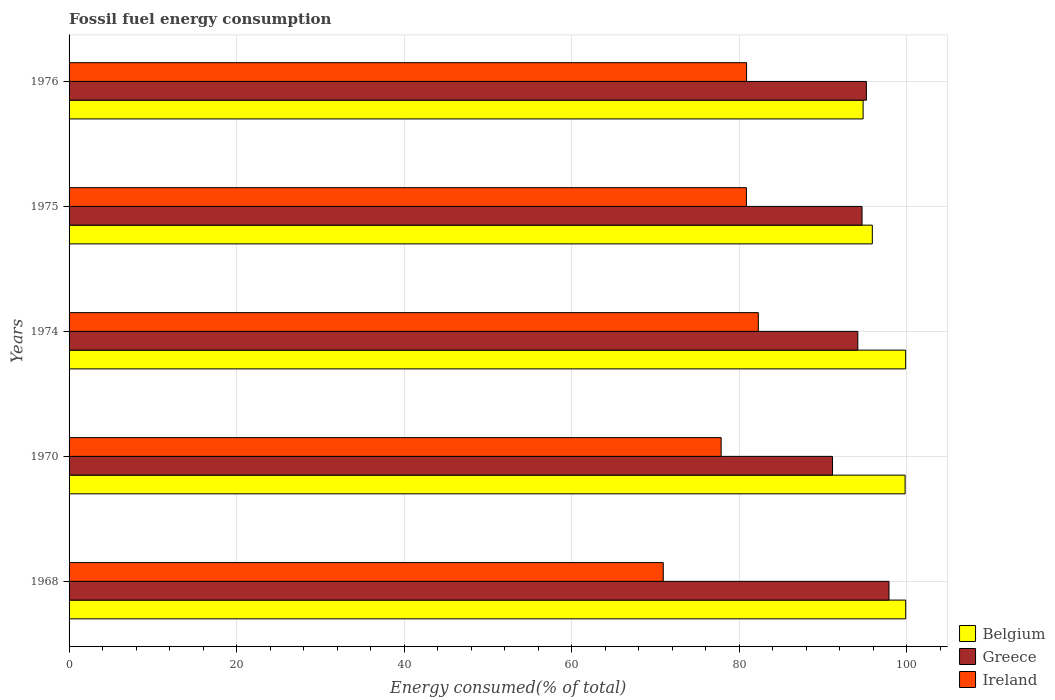How many different coloured bars are there?
Provide a short and direct response. 3. What is the label of the 5th group of bars from the top?
Offer a terse response. 1968. What is the percentage of energy consumed in Belgium in 1975?
Offer a very short reply. 95.91. Across all years, what is the maximum percentage of energy consumed in Belgium?
Keep it short and to the point. 99.9. Across all years, what is the minimum percentage of energy consumed in Greece?
Offer a very short reply. 91.16. In which year was the percentage of energy consumed in Belgium maximum?
Your answer should be compact. 1968. What is the total percentage of energy consumed in Ireland in the graph?
Give a very brief answer. 392.9. What is the difference between the percentage of energy consumed in Belgium in 1974 and that in 1976?
Ensure brevity in your answer.  5.08. What is the difference between the percentage of energy consumed in Belgium in 1968 and the percentage of energy consumed in Ireland in 1974?
Offer a terse response. 17.6. What is the average percentage of energy consumed in Belgium per year?
Give a very brief answer. 98.07. In the year 1974, what is the difference between the percentage of energy consumed in Greece and percentage of energy consumed in Belgium?
Ensure brevity in your answer.  -5.71. What is the ratio of the percentage of energy consumed in Ireland in 1970 to that in 1975?
Provide a short and direct response. 0.96. Is the difference between the percentage of energy consumed in Greece in 1968 and 1974 greater than the difference between the percentage of energy consumed in Belgium in 1968 and 1974?
Offer a terse response. Yes. What is the difference between the highest and the second highest percentage of energy consumed in Greece?
Your response must be concise. 2.7. What is the difference between the highest and the lowest percentage of energy consumed in Ireland?
Your answer should be very brief. 11.35. What does the 3rd bar from the top in 1974 represents?
Your response must be concise. Belgium. What does the 3rd bar from the bottom in 1975 represents?
Provide a succinct answer. Ireland. Is it the case that in every year, the sum of the percentage of energy consumed in Greece and percentage of energy consumed in Ireland is greater than the percentage of energy consumed in Belgium?
Offer a terse response. Yes. How many years are there in the graph?
Your response must be concise. 5. Does the graph contain any zero values?
Provide a succinct answer. No. Does the graph contain grids?
Provide a short and direct response. Yes. How many legend labels are there?
Ensure brevity in your answer.  3. What is the title of the graph?
Provide a short and direct response. Fossil fuel energy consumption. What is the label or title of the X-axis?
Your answer should be very brief. Energy consumed(% of total). What is the label or title of the Y-axis?
Offer a terse response. Years. What is the Energy consumed(% of total) of Belgium in 1968?
Your response must be concise. 99.9. What is the Energy consumed(% of total) of Greece in 1968?
Your answer should be very brief. 97.91. What is the Energy consumed(% of total) of Ireland in 1968?
Provide a short and direct response. 70.95. What is the Energy consumed(% of total) in Belgium in 1970?
Offer a terse response. 99.83. What is the Energy consumed(% of total) of Greece in 1970?
Make the answer very short. 91.16. What is the Energy consumed(% of total) in Ireland in 1970?
Make the answer very short. 77.86. What is the Energy consumed(% of total) of Belgium in 1974?
Provide a succinct answer. 99.89. What is the Energy consumed(% of total) of Greece in 1974?
Give a very brief answer. 94.18. What is the Energy consumed(% of total) in Ireland in 1974?
Provide a short and direct response. 82.3. What is the Energy consumed(% of total) in Belgium in 1975?
Your response must be concise. 95.91. What is the Energy consumed(% of total) in Greece in 1975?
Your response must be concise. 94.69. What is the Energy consumed(% of total) in Ireland in 1975?
Your answer should be compact. 80.88. What is the Energy consumed(% of total) in Belgium in 1976?
Keep it short and to the point. 94.81. What is the Energy consumed(% of total) of Greece in 1976?
Your answer should be very brief. 95.21. What is the Energy consumed(% of total) of Ireland in 1976?
Provide a succinct answer. 80.9. Across all years, what is the maximum Energy consumed(% of total) in Belgium?
Offer a terse response. 99.9. Across all years, what is the maximum Energy consumed(% of total) of Greece?
Offer a terse response. 97.91. Across all years, what is the maximum Energy consumed(% of total) in Ireland?
Offer a very short reply. 82.3. Across all years, what is the minimum Energy consumed(% of total) of Belgium?
Provide a succinct answer. 94.81. Across all years, what is the minimum Energy consumed(% of total) in Greece?
Provide a short and direct response. 91.16. Across all years, what is the minimum Energy consumed(% of total) of Ireland?
Offer a very short reply. 70.95. What is the total Energy consumed(% of total) of Belgium in the graph?
Provide a short and direct response. 490.35. What is the total Energy consumed(% of total) in Greece in the graph?
Offer a terse response. 473.14. What is the total Energy consumed(% of total) of Ireland in the graph?
Give a very brief answer. 392.9. What is the difference between the Energy consumed(% of total) of Belgium in 1968 and that in 1970?
Give a very brief answer. 0.07. What is the difference between the Energy consumed(% of total) of Greece in 1968 and that in 1970?
Provide a succinct answer. 6.75. What is the difference between the Energy consumed(% of total) in Ireland in 1968 and that in 1970?
Your answer should be very brief. -6.91. What is the difference between the Energy consumed(% of total) of Belgium in 1968 and that in 1974?
Provide a short and direct response. 0.01. What is the difference between the Energy consumed(% of total) of Greece in 1968 and that in 1974?
Your answer should be compact. 3.72. What is the difference between the Energy consumed(% of total) in Ireland in 1968 and that in 1974?
Offer a terse response. -11.35. What is the difference between the Energy consumed(% of total) in Belgium in 1968 and that in 1975?
Your answer should be compact. 3.99. What is the difference between the Energy consumed(% of total) in Greece in 1968 and that in 1975?
Keep it short and to the point. 3.22. What is the difference between the Energy consumed(% of total) of Ireland in 1968 and that in 1975?
Your answer should be very brief. -9.93. What is the difference between the Energy consumed(% of total) of Belgium in 1968 and that in 1976?
Provide a short and direct response. 5.09. What is the difference between the Energy consumed(% of total) in Greece in 1968 and that in 1976?
Your answer should be very brief. 2.7. What is the difference between the Energy consumed(% of total) in Ireland in 1968 and that in 1976?
Ensure brevity in your answer.  -9.95. What is the difference between the Energy consumed(% of total) of Belgium in 1970 and that in 1974?
Offer a very short reply. -0.07. What is the difference between the Energy consumed(% of total) of Greece in 1970 and that in 1974?
Ensure brevity in your answer.  -3.02. What is the difference between the Energy consumed(% of total) in Ireland in 1970 and that in 1974?
Offer a terse response. -4.44. What is the difference between the Energy consumed(% of total) of Belgium in 1970 and that in 1975?
Offer a terse response. 3.92. What is the difference between the Energy consumed(% of total) of Greece in 1970 and that in 1975?
Provide a short and direct response. -3.53. What is the difference between the Energy consumed(% of total) in Ireland in 1970 and that in 1975?
Provide a short and direct response. -3.02. What is the difference between the Energy consumed(% of total) in Belgium in 1970 and that in 1976?
Your answer should be compact. 5.02. What is the difference between the Energy consumed(% of total) in Greece in 1970 and that in 1976?
Keep it short and to the point. -4.05. What is the difference between the Energy consumed(% of total) of Ireland in 1970 and that in 1976?
Give a very brief answer. -3.04. What is the difference between the Energy consumed(% of total) in Belgium in 1974 and that in 1975?
Your answer should be compact. 3.98. What is the difference between the Energy consumed(% of total) of Greece in 1974 and that in 1975?
Make the answer very short. -0.51. What is the difference between the Energy consumed(% of total) in Ireland in 1974 and that in 1975?
Provide a short and direct response. 1.42. What is the difference between the Energy consumed(% of total) of Belgium in 1974 and that in 1976?
Offer a terse response. 5.08. What is the difference between the Energy consumed(% of total) in Greece in 1974 and that in 1976?
Keep it short and to the point. -1.02. What is the difference between the Energy consumed(% of total) of Ireland in 1974 and that in 1976?
Offer a very short reply. 1.4. What is the difference between the Energy consumed(% of total) in Belgium in 1975 and that in 1976?
Make the answer very short. 1.1. What is the difference between the Energy consumed(% of total) of Greece in 1975 and that in 1976?
Keep it short and to the point. -0.52. What is the difference between the Energy consumed(% of total) in Ireland in 1975 and that in 1976?
Keep it short and to the point. -0.02. What is the difference between the Energy consumed(% of total) in Belgium in 1968 and the Energy consumed(% of total) in Greece in 1970?
Provide a succinct answer. 8.74. What is the difference between the Energy consumed(% of total) in Belgium in 1968 and the Energy consumed(% of total) in Ireland in 1970?
Keep it short and to the point. 22.04. What is the difference between the Energy consumed(% of total) in Greece in 1968 and the Energy consumed(% of total) in Ireland in 1970?
Ensure brevity in your answer.  20.04. What is the difference between the Energy consumed(% of total) of Belgium in 1968 and the Energy consumed(% of total) of Greece in 1974?
Give a very brief answer. 5.72. What is the difference between the Energy consumed(% of total) of Belgium in 1968 and the Energy consumed(% of total) of Ireland in 1974?
Offer a very short reply. 17.6. What is the difference between the Energy consumed(% of total) of Greece in 1968 and the Energy consumed(% of total) of Ireland in 1974?
Your response must be concise. 15.61. What is the difference between the Energy consumed(% of total) in Belgium in 1968 and the Energy consumed(% of total) in Greece in 1975?
Your response must be concise. 5.21. What is the difference between the Energy consumed(% of total) in Belgium in 1968 and the Energy consumed(% of total) in Ireland in 1975?
Your answer should be compact. 19.02. What is the difference between the Energy consumed(% of total) in Greece in 1968 and the Energy consumed(% of total) in Ireland in 1975?
Ensure brevity in your answer.  17.02. What is the difference between the Energy consumed(% of total) in Belgium in 1968 and the Energy consumed(% of total) in Greece in 1976?
Make the answer very short. 4.69. What is the difference between the Energy consumed(% of total) of Belgium in 1968 and the Energy consumed(% of total) of Ireland in 1976?
Provide a succinct answer. 19. What is the difference between the Energy consumed(% of total) of Greece in 1968 and the Energy consumed(% of total) of Ireland in 1976?
Keep it short and to the point. 17. What is the difference between the Energy consumed(% of total) of Belgium in 1970 and the Energy consumed(% of total) of Greece in 1974?
Provide a short and direct response. 5.65. What is the difference between the Energy consumed(% of total) of Belgium in 1970 and the Energy consumed(% of total) of Ireland in 1974?
Give a very brief answer. 17.53. What is the difference between the Energy consumed(% of total) of Greece in 1970 and the Energy consumed(% of total) of Ireland in 1974?
Offer a terse response. 8.86. What is the difference between the Energy consumed(% of total) in Belgium in 1970 and the Energy consumed(% of total) in Greece in 1975?
Your answer should be very brief. 5.14. What is the difference between the Energy consumed(% of total) in Belgium in 1970 and the Energy consumed(% of total) in Ireland in 1975?
Provide a succinct answer. 18.95. What is the difference between the Energy consumed(% of total) of Greece in 1970 and the Energy consumed(% of total) of Ireland in 1975?
Provide a short and direct response. 10.28. What is the difference between the Energy consumed(% of total) in Belgium in 1970 and the Energy consumed(% of total) in Greece in 1976?
Your answer should be very brief. 4.62. What is the difference between the Energy consumed(% of total) of Belgium in 1970 and the Energy consumed(% of total) of Ireland in 1976?
Give a very brief answer. 18.93. What is the difference between the Energy consumed(% of total) in Greece in 1970 and the Energy consumed(% of total) in Ireland in 1976?
Provide a succinct answer. 10.26. What is the difference between the Energy consumed(% of total) in Belgium in 1974 and the Energy consumed(% of total) in Greece in 1975?
Keep it short and to the point. 5.21. What is the difference between the Energy consumed(% of total) in Belgium in 1974 and the Energy consumed(% of total) in Ireland in 1975?
Your answer should be very brief. 19.01. What is the difference between the Energy consumed(% of total) of Greece in 1974 and the Energy consumed(% of total) of Ireland in 1975?
Keep it short and to the point. 13.3. What is the difference between the Energy consumed(% of total) in Belgium in 1974 and the Energy consumed(% of total) in Greece in 1976?
Your response must be concise. 4.69. What is the difference between the Energy consumed(% of total) of Belgium in 1974 and the Energy consumed(% of total) of Ireland in 1976?
Offer a terse response. 18.99. What is the difference between the Energy consumed(% of total) in Greece in 1974 and the Energy consumed(% of total) in Ireland in 1976?
Provide a succinct answer. 13.28. What is the difference between the Energy consumed(% of total) of Belgium in 1975 and the Energy consumed(% of total) of Greece in 1976?
Give a very brief answer. 0.71. What is the difference between the Energy consumed(% of total) of Belgium in 1975 and the Energy consumed(% of total) of Ireland in 1976?
Give a very brief answer. 15.01. What is the difference between the Energy consumed(% of total) of Greece in 1975 and the Energy consumed(% of total) of Ireland in 1976?
Offer a very short reply. 13.79. What is the average Energy consumed(% of total) of Belgium per year?
Offer a terse response. 98.07. What is the average Energy consumed(% of total) in Greece per year?
Provide a short and direct response. 94.63. What is the average Energy consumed(% of total) of Ireland per year?
Offer a very short reply. 78.58. In the year 1968, what is the difference between the Energy consumed(% of total) in Belgium and Energy consumed(% of total) in Greece?
Offer a very short reply. 2. In the year 1968, what is the difference between the Energy consumed(% of total) of Belgium and Energy consumed(% of total) of Ireland?
Your answer should be compact. 28.95. In the year 1968, what is the difference between the Energy consumed(% of total) of Greece and Energy consumed(% of total) of Ireland?
Provide a succinct answer. 26.95. In the year 1970, what is the difference between the Energy consumed(% of total) of Belgium and Energy consumed(% of total) of Greece?
Ensure brevity in your answer.  8.67. In the year 1970, what is the difference between the Energy consumed(% of total) of Belgium and Energy consumed(% of total) of Ireland?
Make the answer very short. 21.97. In the year 1970, what is the difference between the Energy consumed(% of total) in Greece and Energy consumed(% of total) in Ireland?
Your answer should be compact. 13.3. In the year 1974, what is the difference between the Energy consumed(% of total) in Belgium and Energy consumed(% of total) in Greece?
Offer a very short reply. 5.71. In the year 1974, what is the difference between the Energy consumed(% of total) of Belgium and Energy consumed(% of total) of Ireland?
Your response must be concise. 17.59. In the year 1974, what is the difference between the Energy consumed(% of total) of Greece and Energy consumed(% of total) of Ireland?
Provide a succinct answer. 11.88. In the year 1975, what is the difference between the Energy consumed(% of total) of Belgium and Energy consumed(% of total) of Greece?
Ensure brevity in your answer.  1.23. In the year 1975, what is the difference between the Energy consumed(% of total) in Belgium and Energy consumed(% of total) in Ireland?
Your response must be concise. 15.03. In the year 1975, what is the difference between the Energy consumed(% of total) of Greece and Energy consumed(% of total) of Ireland?
Keep it short and to the point. 13.81. In the year 1976, what is the difference between the Energy consumed(% of total) of Belgium and Energy consumed(% of total) of Greece?
Offer a very short reply. -0.39. In the year 1976, what is the difference between the Energy consumed(% of total) of Belgium and Energy consumed(% of total) of Ireland?
Ensure brevity in your answer.  13.91. In the year 1976, what is the difference between the Energy consumed(% of total) of Greece and Energy consumed(% of total) of Ireland?
Provide a short and direct response. 14.3. What is the ratio of the Energy consumed(% of total) in Belgium in 1968 to that in 1970?
Offer a very short reply. 1. What is the ratio of the Energy consumed(% of total) in Greece in 1968 to that in 1970?
Your answer should be very brief. 1.07. What is the ratio of the Energy consumed(% of total) of Ireland in 1968 to that in 1970?
Provide a succinct answer. 0.91. What is the ratio of the Energy consumed(% of total) in Belgium in 1968 to that in 1974?
Your answer should be compact. 1. What is the ratio of the Energy consumed(% of total) in Greece in 1968 to that in 1974?
Your answer should be compact. 1.04. What is the ratio of the Energy consumed(% of total) in Ireland in 1968 to that in 1974?
Your response must be concise. 0.86. What is the ratio of the Energy consumed(% of total) of Belgium in 1968 to that in 1975?
Keep it short and to the point. 1.04. What is the ratio of the Energy consumed(% of total) of Greece in 1968 to that in 1975?
Offer a terse response. 1.03. What is the ratio of the Energy consumed(% of total) in Ireland in 1968 to that in 1975?
Ensure brevity in your answer.  0.88. What is the ratio of the Energy consumed(% of total) of Belgium in 1968 to that in 1976?
Give a very brief answer. 1.05. What is the ratio of the Energy consumed(% of total) in Greece in 1968 to that in 1976?
Your answer should be compact. 1.03. What is the ratio of the Energy consumed(% of total) of Ireland in 1968 to that in 1976?
Provide a succinct answer. 0.88. What is the ratio of the Energy consumed(% of total) in Greece in 1970 to that in 1974?
Keep it short and to the point. 0.97. What is the ratio of the Energy consumed(% of total) in Ireland in 1970 to that in 1974?
Provide a succinct answer. 0.95. What is the ratio of the Energy consumed(% of total) in Belgium in 1970 to that in 1975?
Your answer should be very brief. 1.04. What is the ratio of the Energy consumed(% of total) of Greece in 1970 to that in 1975?
Provide a short and direct response. 0.96. What is the ratio of the Energy consumed(% of total) of Ireland in 1970 to that in 1975?
Make the answer very short. 0.96. What is the ratio of the Energy consumed(% of total) of Belgium in 1970 to that in 1976?
Give a very brief answer. 1.05. What is the ratio of the Energy consumed(% of total) of Greece in 1970 to that in 1976?
Keep it short and to the point. 0.96. What is the ratio of the Energy consumed(% of total) of Ireland in 1970 to that in 1976?
Keep it short and to the point. 0.96. What is the ratio of the Energy consumed(% of total) in Belgium in 1974 to that in 1975?
Offer a very short reply. 1.04. What is the ratio of the Energy consumed(% of total) in Ireland in 1974 to that in 1975?
Your answer should be compact. 1.02. What is the ratio of the Energy consumed(% of total) of Belgium in 1974 to that in 1976?
Ensure brevity in your answer.  1.05. What is the ratio of the Energy consumed(% of total) in Ireland in 1974 to that in 1976?
Make the answer very short. 1.02. What is the ratio of the Energy consumed(% of total) of Belgium in 1975 to that in 1976?
Offer a very short reply. 1.01. What is the ratio of the Energy consumed(% of total) in Greece in 1975 to that in 1976?
Your answer should be very brief. 0.99. What is the ratio of the Energy consumed(% of total) in Ireland in 1975 to that in 1976?
Make the answer very short. 1. What is the difference between the highest and the second highest Energy consumed(% of total) of Belgium?
Make the answer very short. 0.01. What is the difference between the highest and the second highest Energy consumed(% of total) of Greece?
Make the answer very short. 2.7. What is the difference between the highest and the second highest Energy consumed(% of total) in Ireland?
Offer a very short reply. 1.4. What is the difference between the highest and the lowest Energy consumed(% of total) of Belgium?
Offer a very short reply. 5.09. What is the difference between the highest and the lowest Energy consumed(% of total) in Greece?
Your answer should be very brief. 6.75. What is the difference between the highest and the lowest Energy consumed(% of total) in Ireland?
Ensure brevity in your answer.  11.35. 